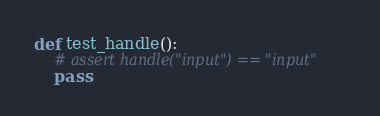<code> <loc_0><loc_0><loc_500><loc_500><_Python_>def test_handle():
    # assert handle("input") == "input"
    pass
</code> 